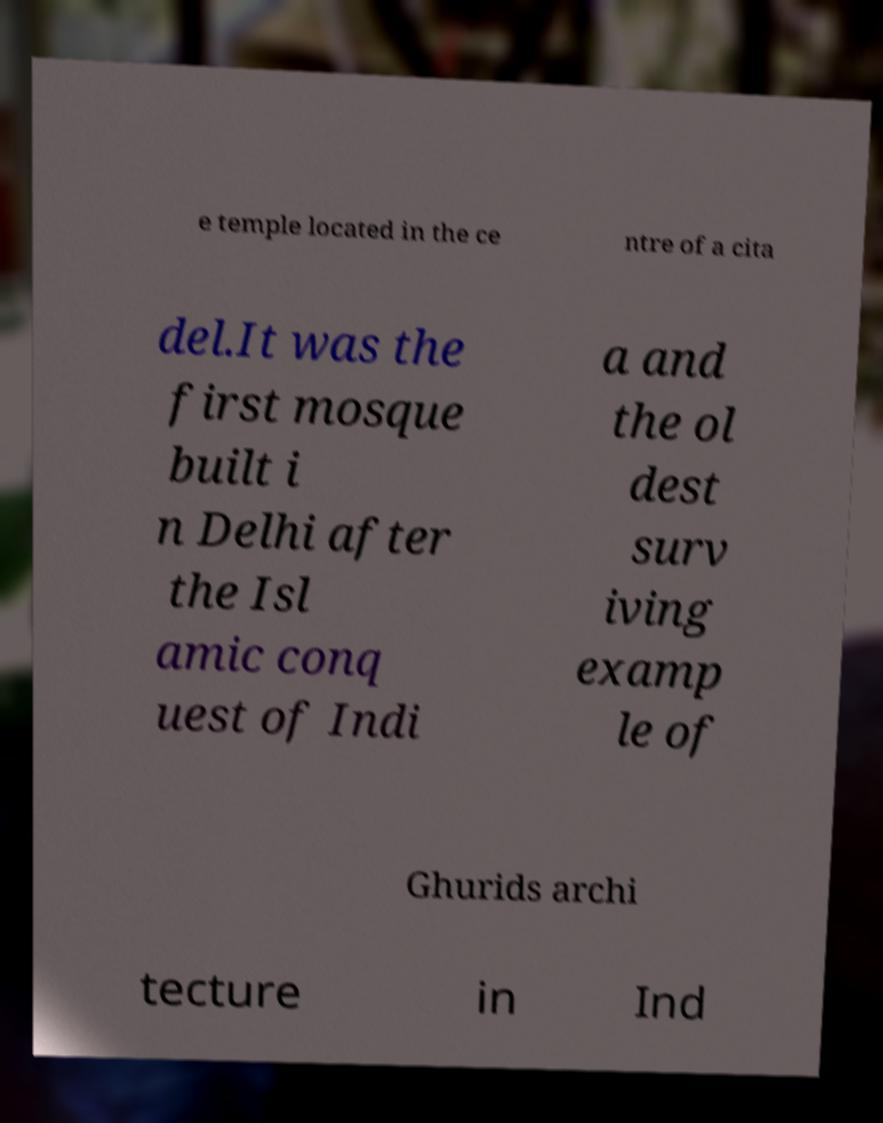Please read and relay the text visible in this image. What does it say? e temple located in the ce ntre of a cita del.It was the first mosque built i n Delhi after the Isl amic conq uest of Indi a and the ol dest surv iving examp le of Ghurids archi tecture in Ind 